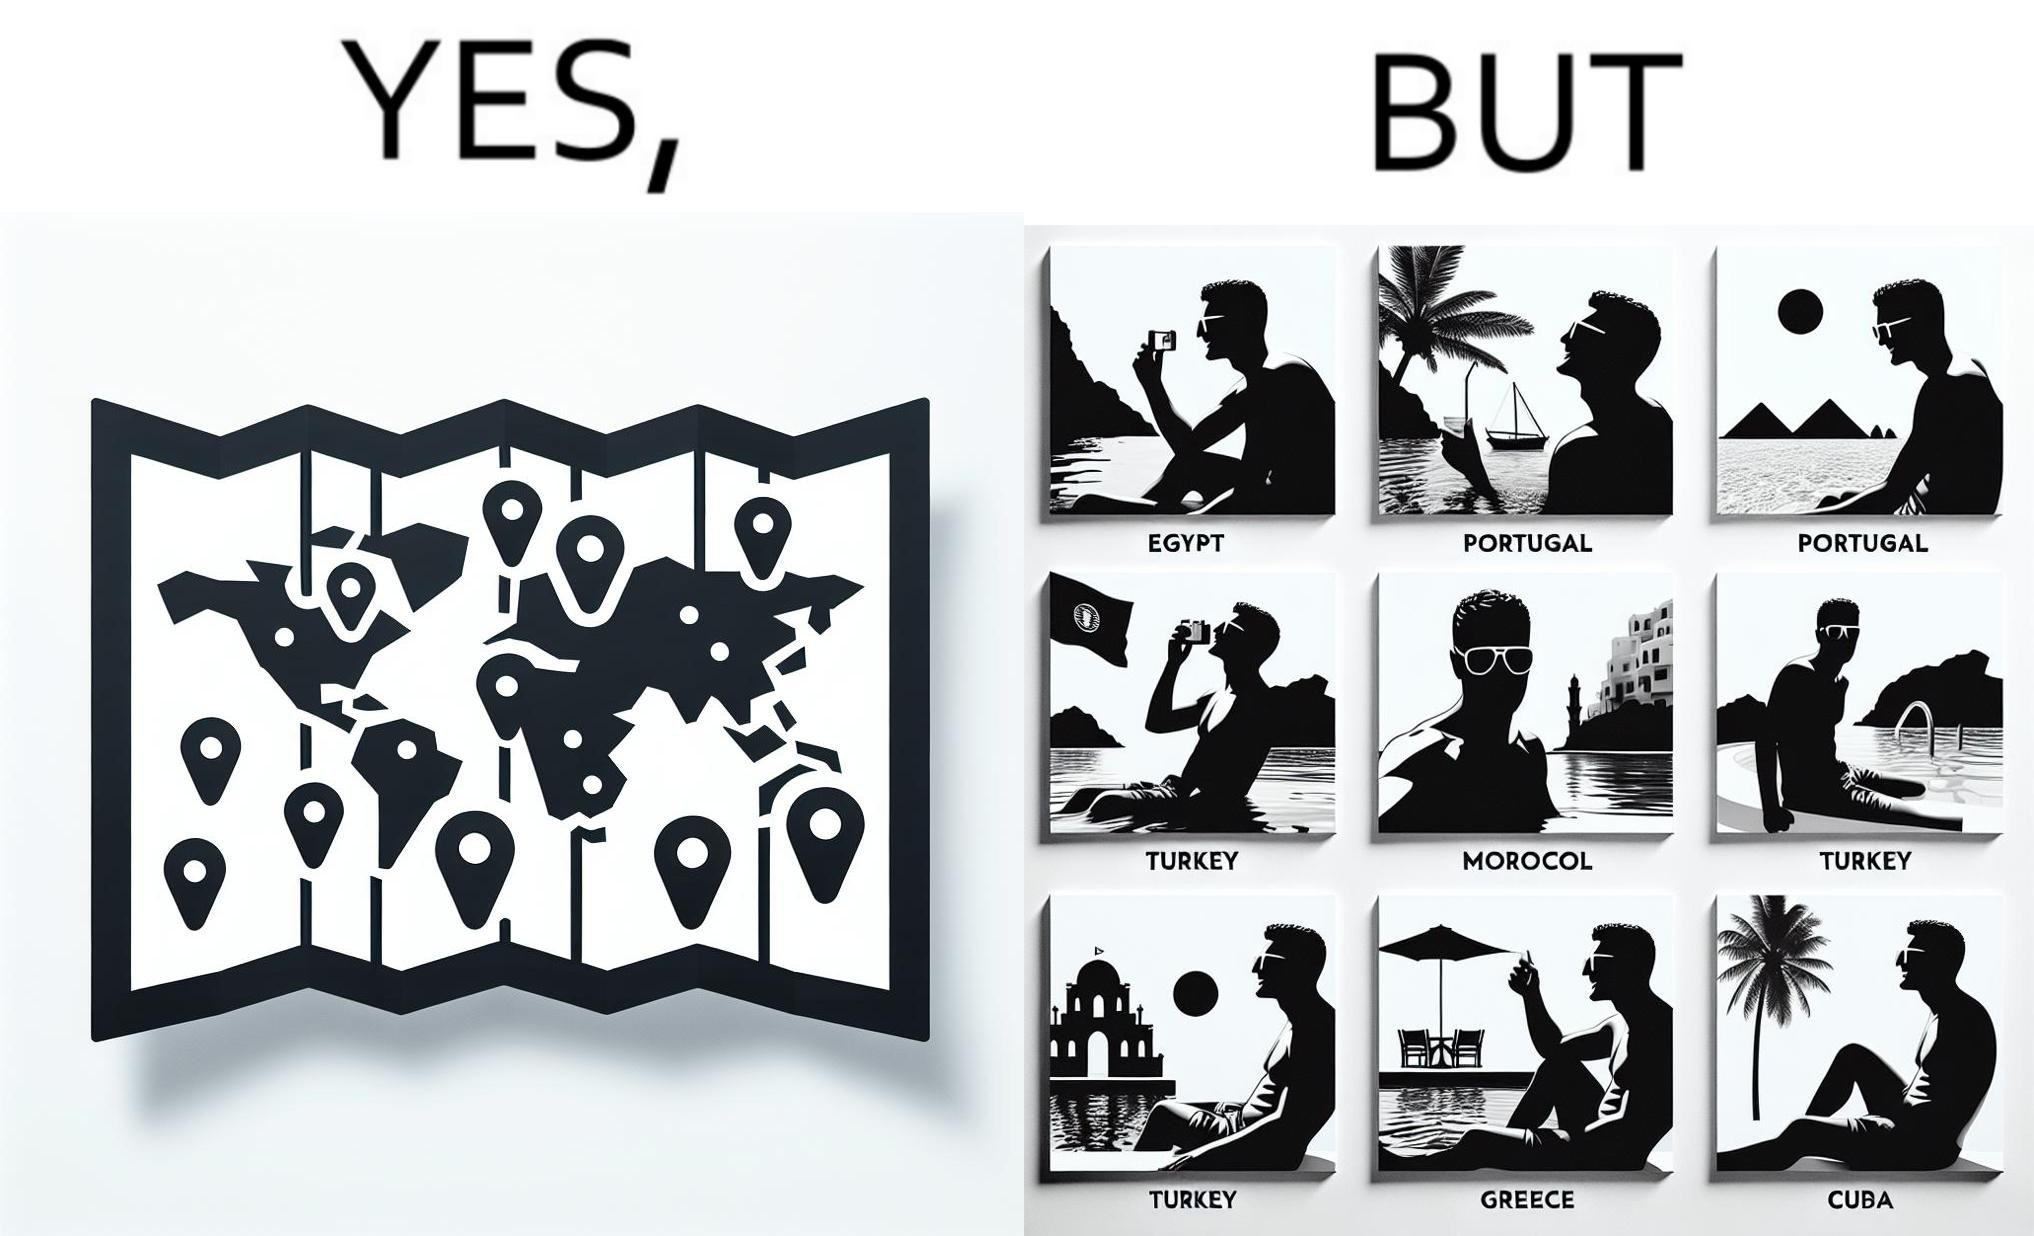Describe the content of this image. The image is satirical because while the man has visited all the place marked on the map, he only seems to have swam in pools in all these differnt countries and has not actually seen these places. 